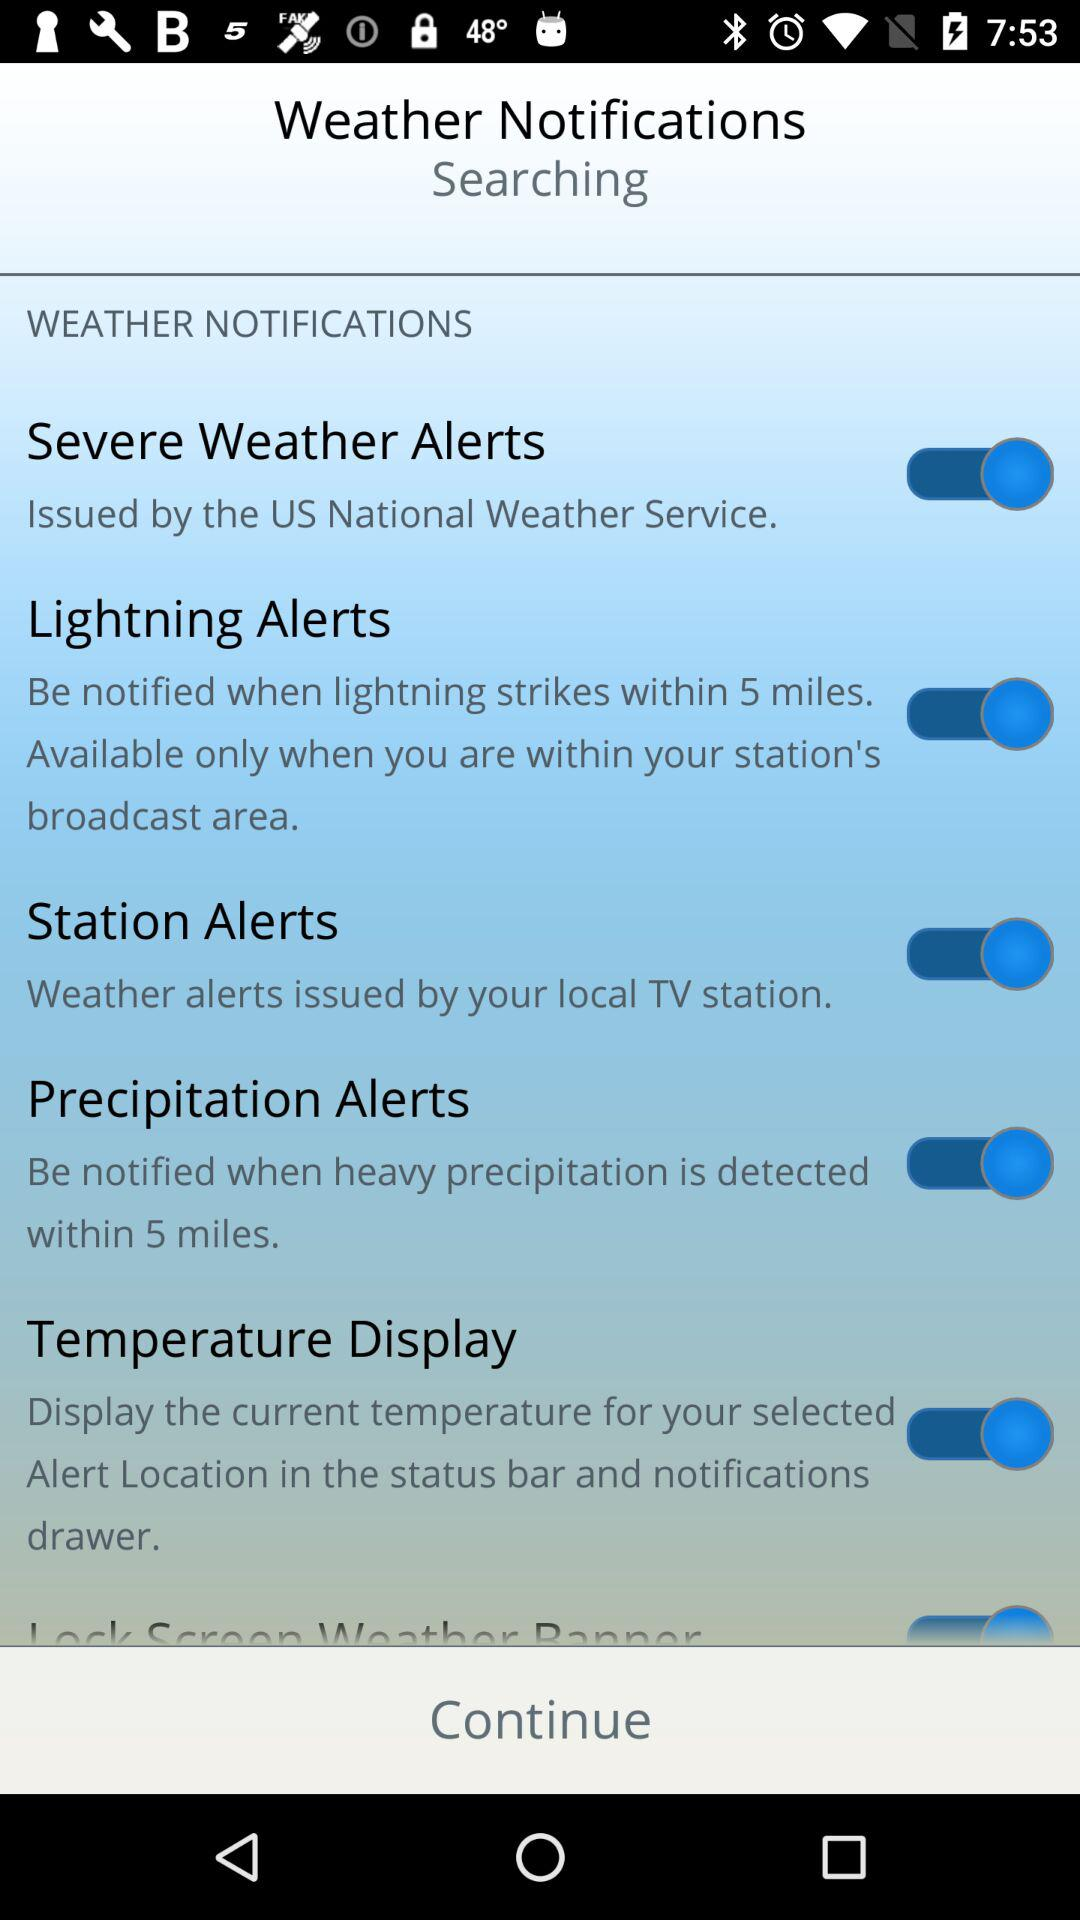What is the status of "Station Alerts"? The status of "Station Alerts" is "on". 